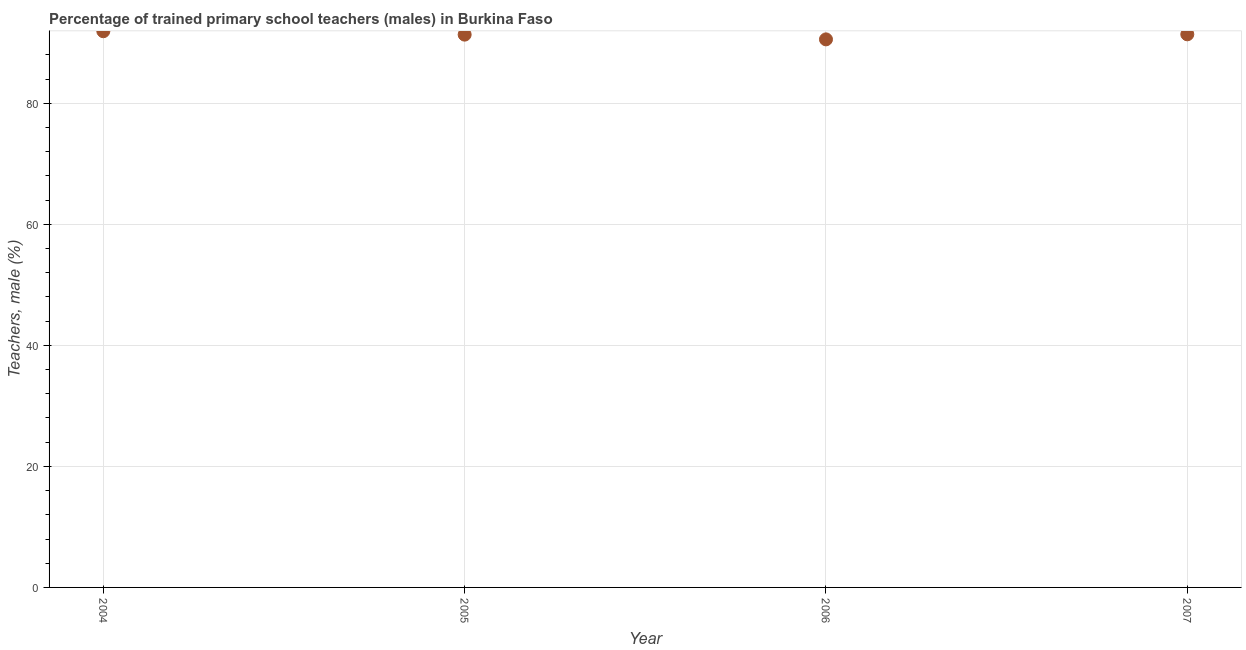What is the percentage of trained male teachers in 2007?
Your response must be concise. 91.4. Across all years, what is the maximum percentage of trained male teachers?
Offer a terse response. 91.91. Across all years, what is the minimum percentage of trained male teachers?
Provide a succinct answer. 90.57. In which year was the percentage of trained male teachers maximum?
Ensure brevity in your answer.  2004. What is the sum of the percentage of trained male teachers?
Offer a very short reply. 365.23. What is the difference between the percentage of trained male teachers in 2004 and 2007?
Keep it short and to the point. 0.51. What is the average percentage of trained male teachers per year?
Your response must be concise. 91.31. What is the median percentage of trained male teachers?
Ensure brevity in your answer.  91.38. In how many years, is the percentage of trained male teachers greater than 24 %?
Your response must be concise. 4. What is the ratio of the percentage of trained male teachers in 2006 to that in 2007?
Give a very brief answer. 0.99. Is the difference between the percentage of trained male teachers in 2006 and 2007 greater than the difference between any two years?
Offer a very short reply. No. What is the difference between the highest and the second highest percentage of trained male teachers?
Make the answer very short. 0.51. Is the sum of the percentage of trained male teachers in 2005 and 2007 greater than the maximum percentage of trained male teachers across all years?
Offer a terse response. Yes. What is the difference between the highest and the lowest percentage of trained male teachers?
Make the answer very short. 1.34. In how many years, is the percentage of trained male teachers greater than the average percentage of trained male teachers taken over all years?
Your answer should be compact. 3. How many dotlines are there?
Make the answer very short. 1. How many years are there in the graph?
Your response must be concise. 4. What is the difference between two consecutive major ticks on the Y-axis?
Keep it short and to the point. 20. Are the values on the major ticks of Y-axis written in scientific E-notation?
Ensure brevity in your answer.  No. Does the graph contain any zero values?
Provide a succinct answer. No. What is the title of the graph?
Ensure brevity in your answer.  Percentage of trained primary school teachers (males) in Burkina Faso. What is the label or title of the X-axis?
Your response must be concise. Year. What is the label or title of the Y-axis?
Provide a short and direct response. Teachers, male (%). What is the Teachers, male (%) in 2004?
Give a very brief answer. 91.91. What is the Teachers, male (%) in 2005?
Provide a succinct answer. 91.35. What is the Teachers, male (%) in 2006?
Provide a short and direct response. 90.57. What is the Teachers, male (%) in 2007?
Ensure brevity in your answer.  91.4. What is the difference between the Teachers, male (%) in 2004 and 2005?
Keep it short and to the point. 0.56. What is the difference between the Teachers, male (%) in 2004 and 2006?
Your answer should be very brief. 1.34. What is the difference between the Teachers, male (%) in 2004 and 2007?
Your answer should be very brief. 0.51. What is the difference between the Teachers, male (%) in 2005 and 2006?
Provide a short and direct response. 0.78. What is the difference between the Teachers, male (%) in 2005 and 2007?
Offer a terse response. -0.05. What is the difference between the Teachers, male (%) in 2006 and 2007?
Offer a very short reply. -0.83. What is the ratio of the Teachers, male (%) in 2004 to that in 2005?
Give a very brief answer. 1.01. What is the ratio of the Teachers, male (%) in 2006 to that in 2007?
Your answer should be compact. 0.99. 